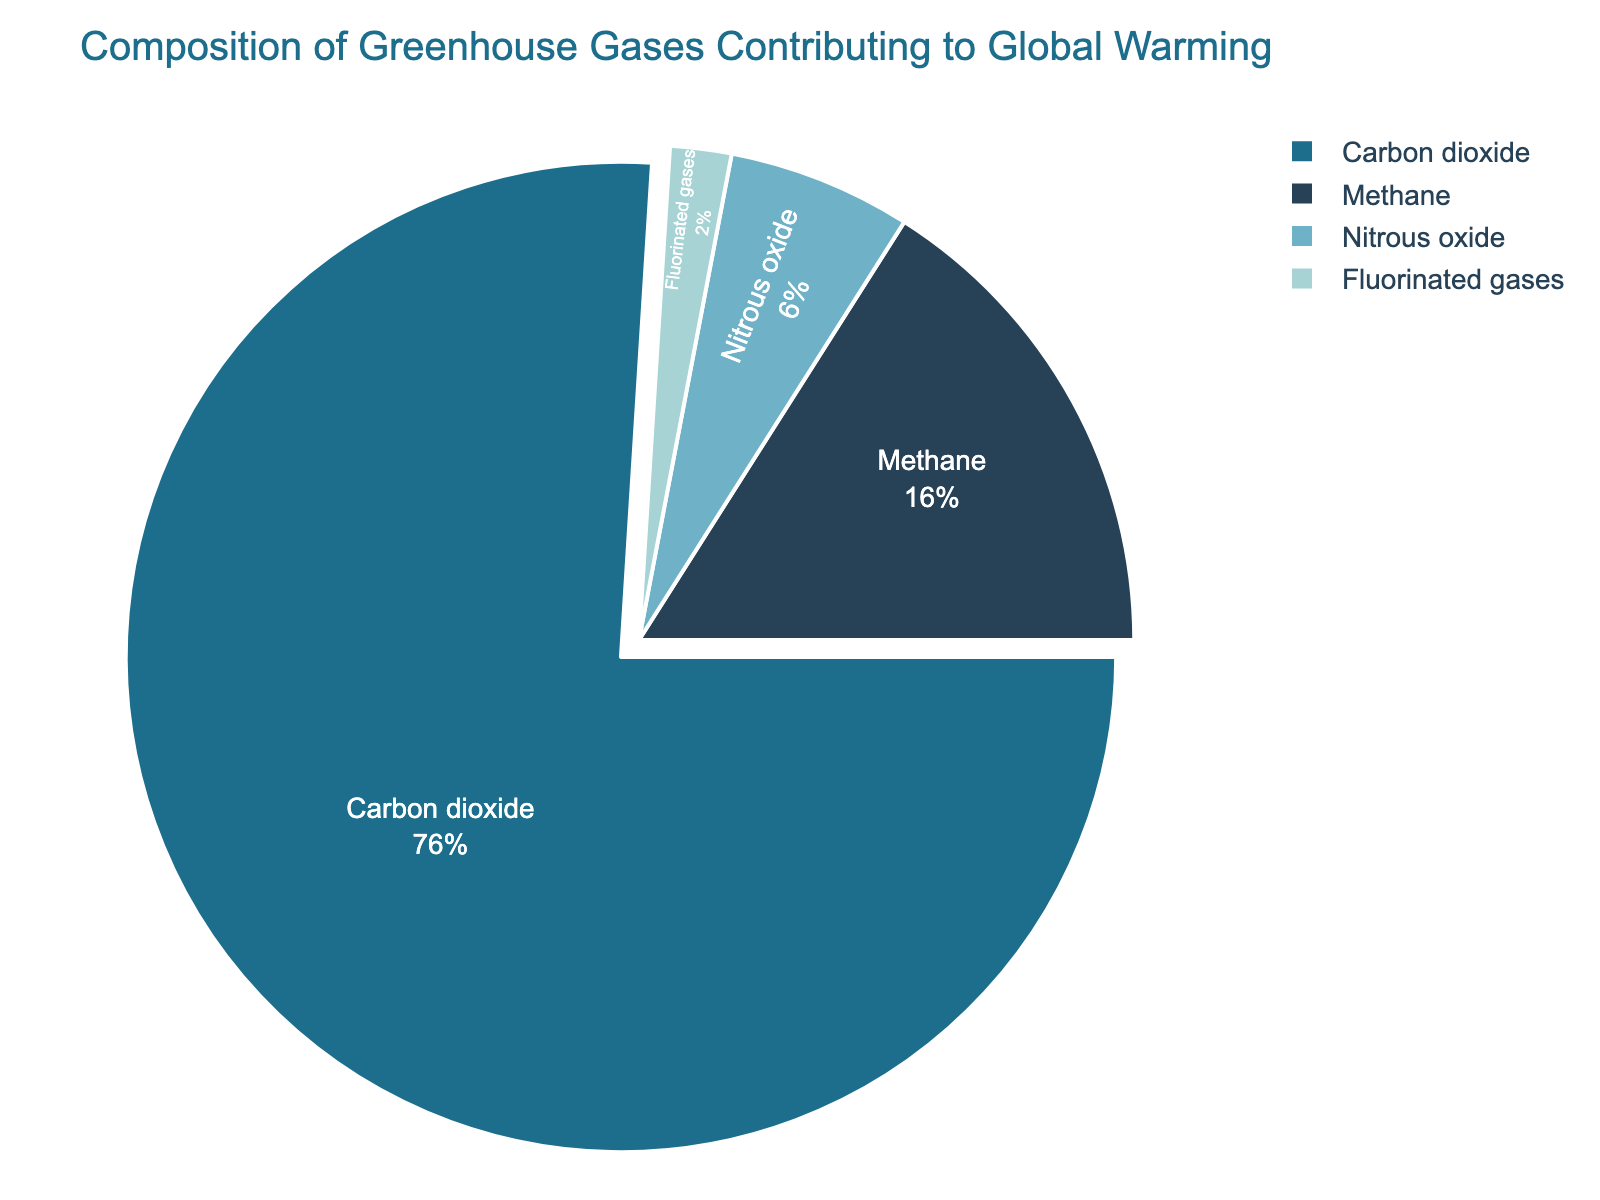What's the percentage of Carbon dioxide? According to the chart, Carbon dioxide makes up 76% of the greenhouse gases.
Answer: 76% What is the total percentage of Methane and Nitrous oxide combined? Methane is 16% and Nitrous oxide is 6%. Adding them together gives: 16% + 6% = 22%.
Answer: 22% Which greenhouse gas has the smallest contribution to global warming? By examining the chart, Fluorinated gases have the smallest contribution at 2%.
Answer: Fluorinated gases How much greater is the percentage of Carbon dioxide compared to Methane? The percentage of Carbon dioxide is 76% and the percentage of Methane is 16%. The difference is 76% - 16% = 60%.
Answer: 60% Is the percentage of Nitrous oxide more or less than 10%? Based on the chart, the percentage of Nitrous oxide is 6%, which is less than 10%.
Answer: Less than 10% What color represents Methane in the chart? The color representing Methane in the chart is a blue hue.
Answer: Blue How many times more does Carbon dioxide contribute to global warming compared to Fluorinated gases? The percentage of Carbon dioxide is 76% and Fluorinated gases is 2%. Dividing Carbon dioxide percentage by Fluorinated gases percentage gives: 76% / 2% = 38 times.
Answer: 38 times What is the difference between the largest and smallest contributions to global warming? The largest contribution is from Carbon dioxide at 76%, and the smallest is from Fluorinated gases at 2%. The difference is 76% - 2% = 74%.
Answer: 74% Which greenhouse gases combined make up more than 80% of the total? Carbon dioxide is 76% and Methane is 16%. Together, they sum up to 76% + 16% = 92%, which is more than 80%.
Answer: Carbon dioxide and Methane What is the color palette theme of the chart? The chart uses a winter color theme with various shades of blue.
Answer: Winter colors 